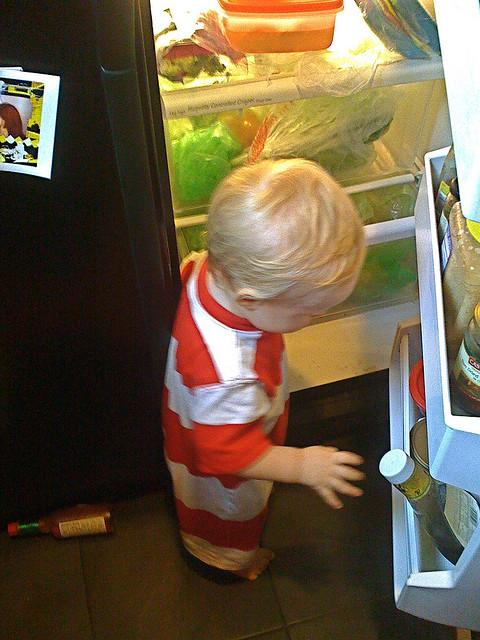What color outfit is the child wearing? red white 